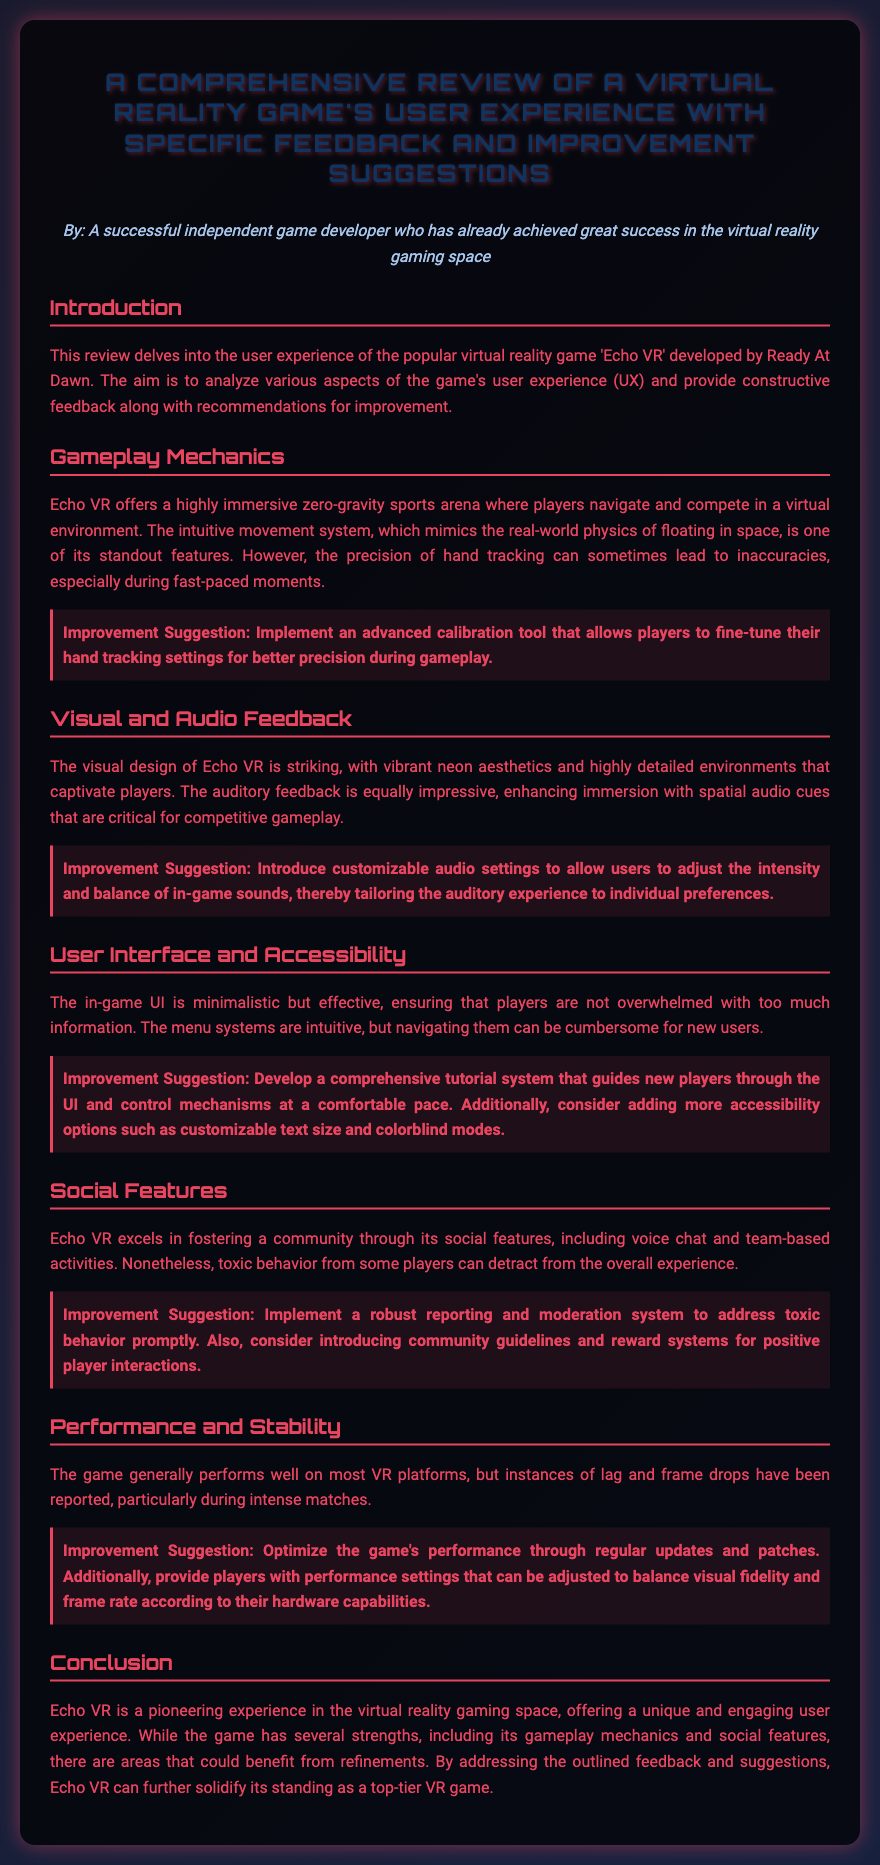What is the title of the review? The title is explicitly mentioned in the document's header as the main focus of the content.
Answer: A Comprehensive Review of a Virtual Reality Game's User Experience with Specific Feedback and Improvement Suggestions Who developed the game 'Echo VR'? The developer's name is explicitly stated in the introductory section of the document.
Answer: Ready At Dawn What is one standout feature of Echo VR? This feature is discussed in the Gameplay Mechanics section, highlighting a specific aspect of the game's design.
Answer: Intuitive movement system What improvement is suggested for hand tracking? The improvement suggestion is given in the Gameplay Mechanics section and specifies a particular tool related to gameplay.
Answer: Advanced calibration tool What type of audio enhancement is recommended? This enhancement is mentioned in the Visual and Audio Feedback section concerning player customization.
Answer: Customizable audio settings What is a reported issue during intense matches? The issue is mentioned in the Performance and Stability section, indicating a specific performance-related problem.
Answer: Lag and frame drops What community feature does Echo VR excel in? This aspect is discussed in the Social Features section, highlighting a critical element of player interaction.
Answer: Voice chat What system is proposed to handle toxic behavior? The improvement suggestion is focused on addressing a specific issue related to player conduct in the game.
Answer: Robust reporting and moderation system What demographic aspect should be considered for the UI? This aspect is mentioned in the User Interface and Accessibility section, indicating the need for broader usability.
Answer: Customizable text size and colorblind modes 